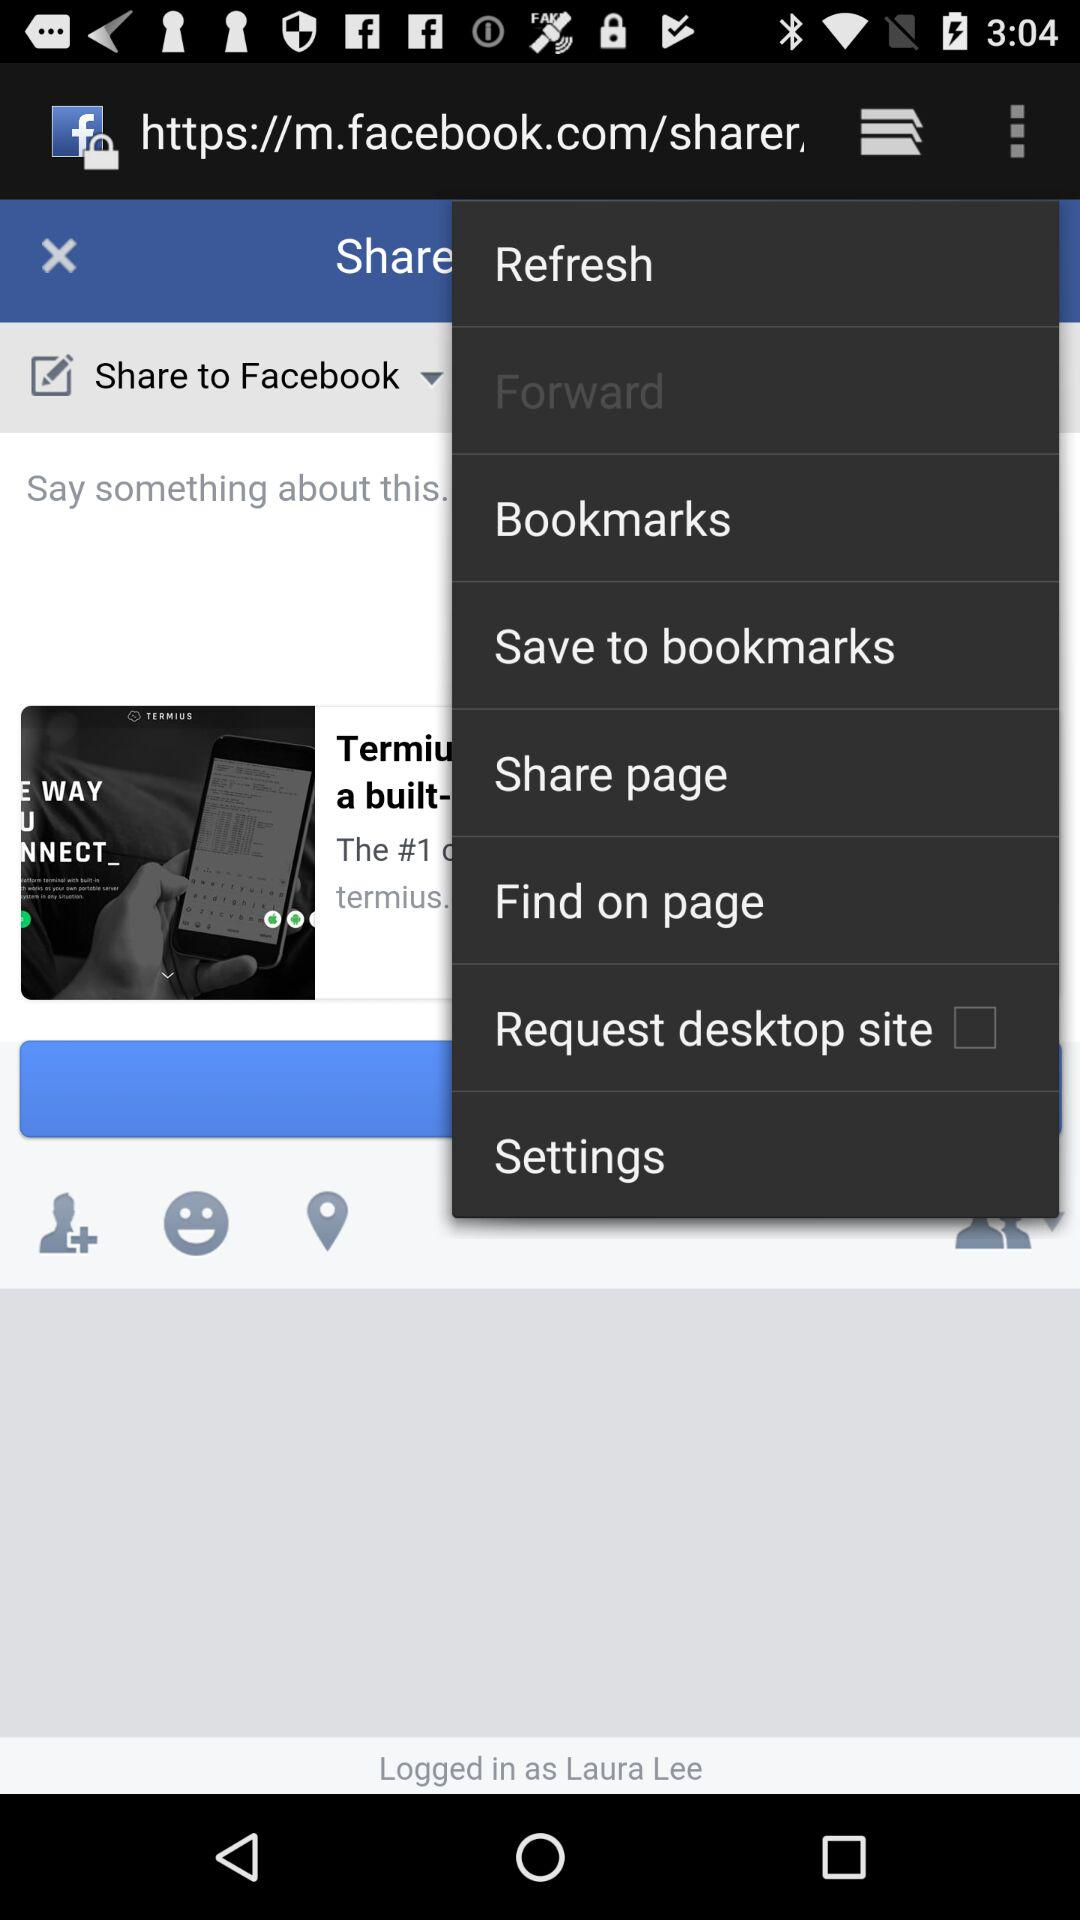Is "Request desktop site" checked or not? "Request desktop site" is not checked. 